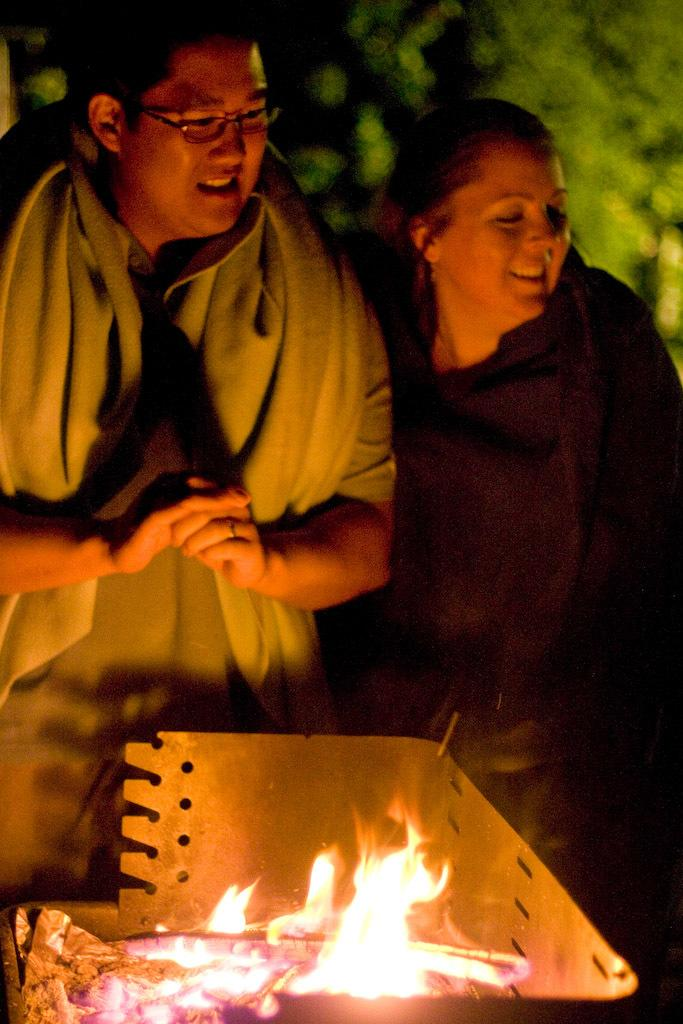How many people are present in the image? There are two people standing in the image. What can be seen in the image besides the people? There is fire visible in the image. What is visible in the background of the image? There are trees in the background of the image. What type of texture can be seen on the foot of the person in the image? There is no foot visible in the image, as both people are standing upright. 